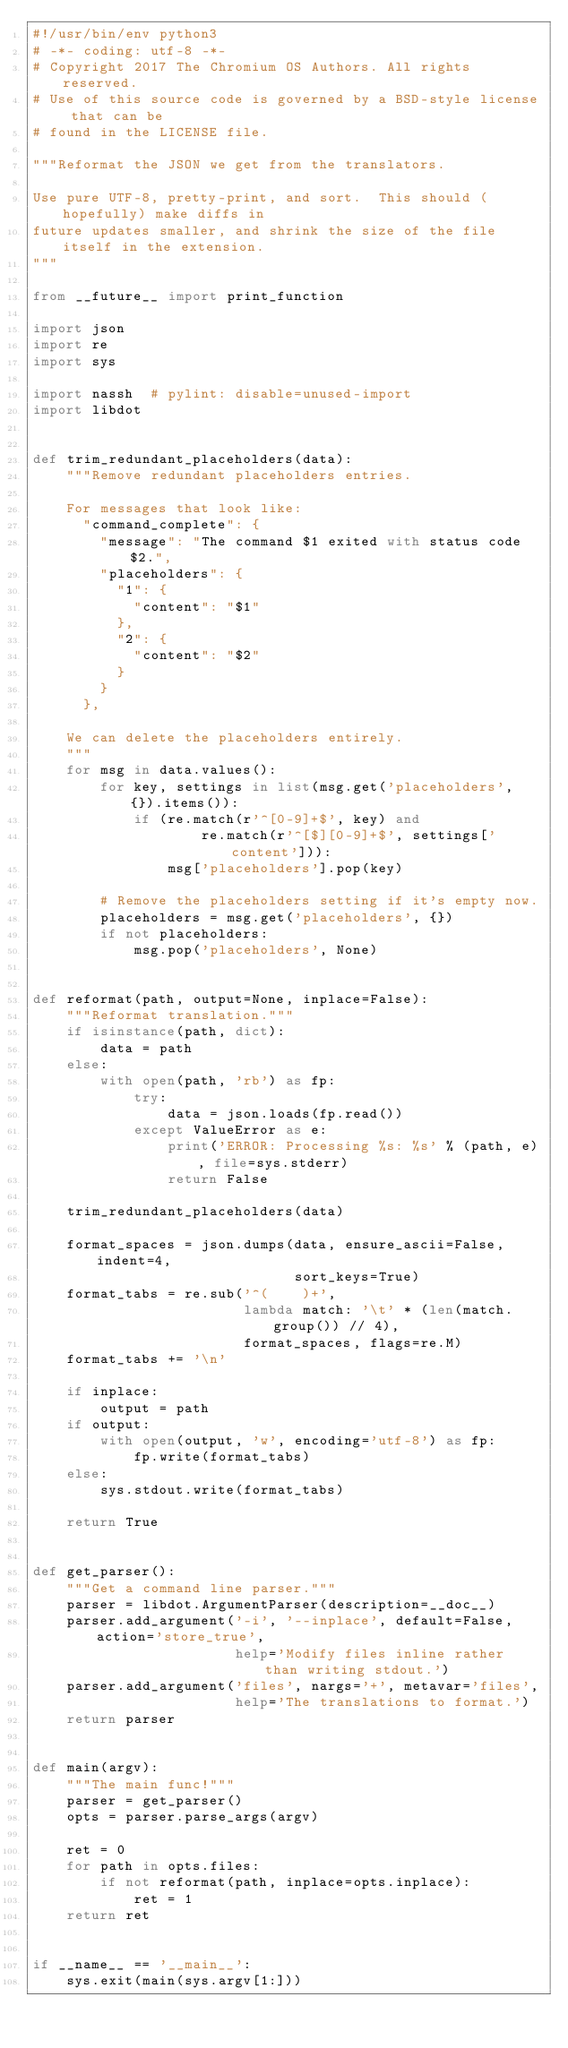<code> <loc_0><loc_0><loc_500><loc_500><_Python_>#!/usr/bin/env python3
# -*- coding: utf-8 -*-
# Copyright 2017 The Chromium OS Authors. All rights reserved.
# Use of this source code is governed by a BSD-style license that can be
# found in the LICENSE file.

"""Reformat the JSON we get from the translators.

Use pure UTF-8, pretty-print, and sort.  This should (hopefully) make diffs in
future updates smaller, and shrink the size of the file itself in the extension.
"""

from __future__ import print_function

import json
import re
import sys

import nassh  # pylint: disable=unused-import
import libdot


def trim_redundant_placeholders(data):
    """Remove redundant placeholders entries.

    For messages that look like:
      "command_complete": {
        "message": "The command $1 exited with status code $2.",
        "placeholders": {
          "1": {
            "content": "$1"
          },
          "2": {
            "content": "$2"
          }
        }
      },

    We can delete the placeholders entirely.
    """
    for msg in data.values():
        for key, settings in list(msg.get('placeholders', {}).items()):
            if (re.match(r'^[0-9]+$', key) and
                    re.match(r'^[$][0-9]+$', settings['content'])):
                msg['placeholders'].pop(key)

        # Remove the placeholders setting if it's empty now.
        placeholders = msg.get('placeholders', {})
        if not placeholders:
            msg.pop('placeholders', None)


def reformat(path, output=None, inplace=False):
    """Reformat translation."""
    if isinstance(path, dict):
        data = path
    else:
        with open(path, 'rb') as fp:
            try:
                data = json.loads(fp.read())
            except ValueError as e:
                print('ERROR: Processing %s: %s' % (path, e), file=sys.stderr)
                return False

    trim_redundant_placeholders(data)

    format_spaces = json.dumps(data, ensure_ascii=False, indent=4,
                               sort_keys=True)
    format_tabs = re.sub('^(    )+',
                         lambda match: '\t' * (len(match.group()) // 4),
                         format_spaces, flags=re.M)
    format_tabs += '\n'

    if inplace:
        output = path
    if output:
        with open(output, 'w', encoding='utf-8') as fp:
            fp.write(format_tabs)
    else:
        sys.stdout.write(format_tabs)

    return True


def get_parser():
    """Get a command line parser."""
    parser = libdot.ArgumentParser(description=__doc__)
    parser.add_argument('-i', '--inplace', default=False, action='store_true',
                        help='Modify files inline rather than writing stdout.')
    parser.add_argument('files', nargs='+', metavar='files',
                        help='The translations to format.')
    return parser


def main(argv):
    """The main func!"""
    parser = get_parser()
    opts = parser.parse_args(argv)

    ret = 0
    for path in opts.files:
        if not reformat(path, inplace=opts.inplace):
            ret = 1
    return ret


if __name__ == '__main__':
    sys.exit(main(sys.argv[1:]))
</code> 